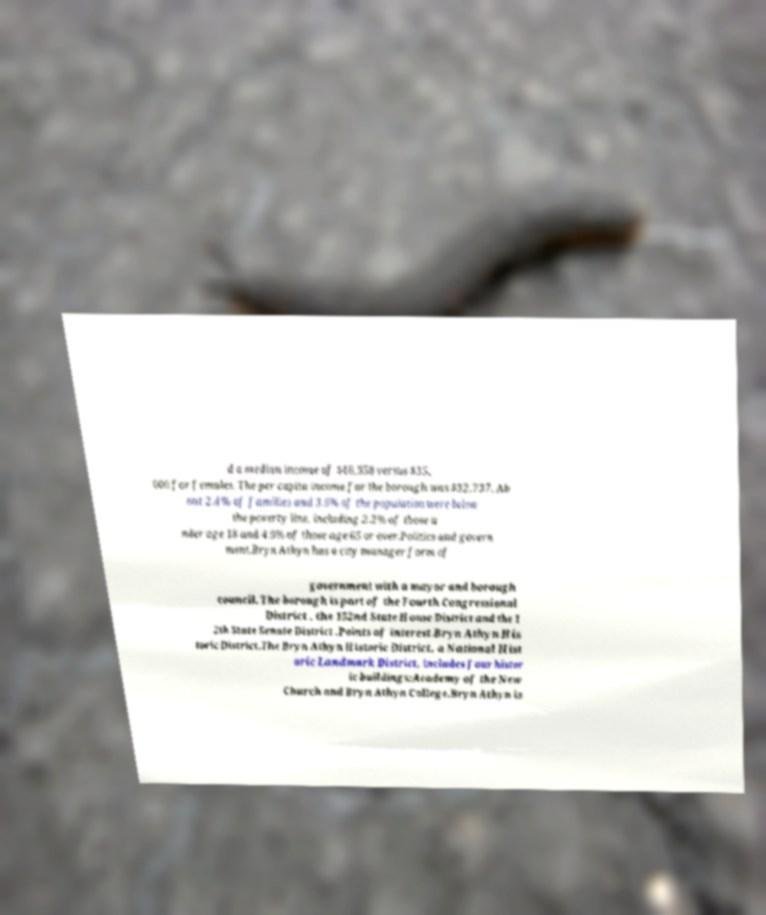Can you read and provide the text displayed in the image?This photo seems to have some interesting text. Can you extract and type it out for me? d a median income of $48,958 versus $35, 000 for females. The per capita income for the borough was $32,737. Ab out 2.4% of families and 3.6% of the population were below the poverty line, including 2.2% of those u nder age 18 and 4.9% of those age 65 or over.Politics and govern ment.Bryn Athyn has a city manager form of government with a mayor and borough council. The borough is part of the Fourth Congressional District , the 152nd State House District and the 1 2th State Senate District .Points of interest.Bryn Athyn His toric District.The Bryn Athyn Historic District, a National Hist oric Landmark District, includes four histor ic buildings:Academy of the New Church and Bryn Athyn College.Bryn Athyn is 